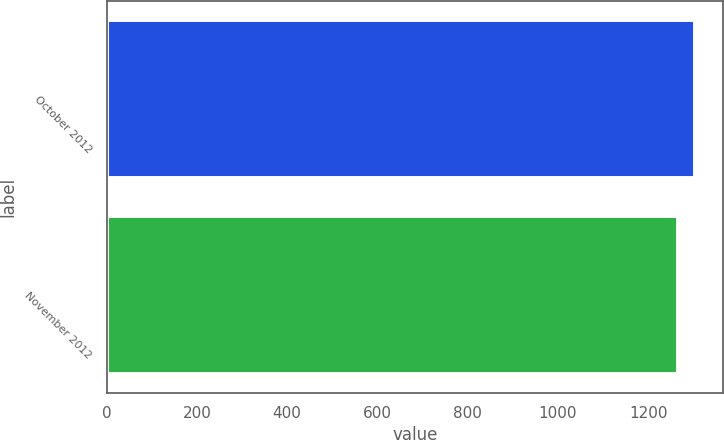<chart> <loc_0><loc_0><loc_500><loc_500><bar_chart><fcel>October 2012<fcel>November 2012<nl><fcel>1300.1<fcel>1263.7<nl></chart> 